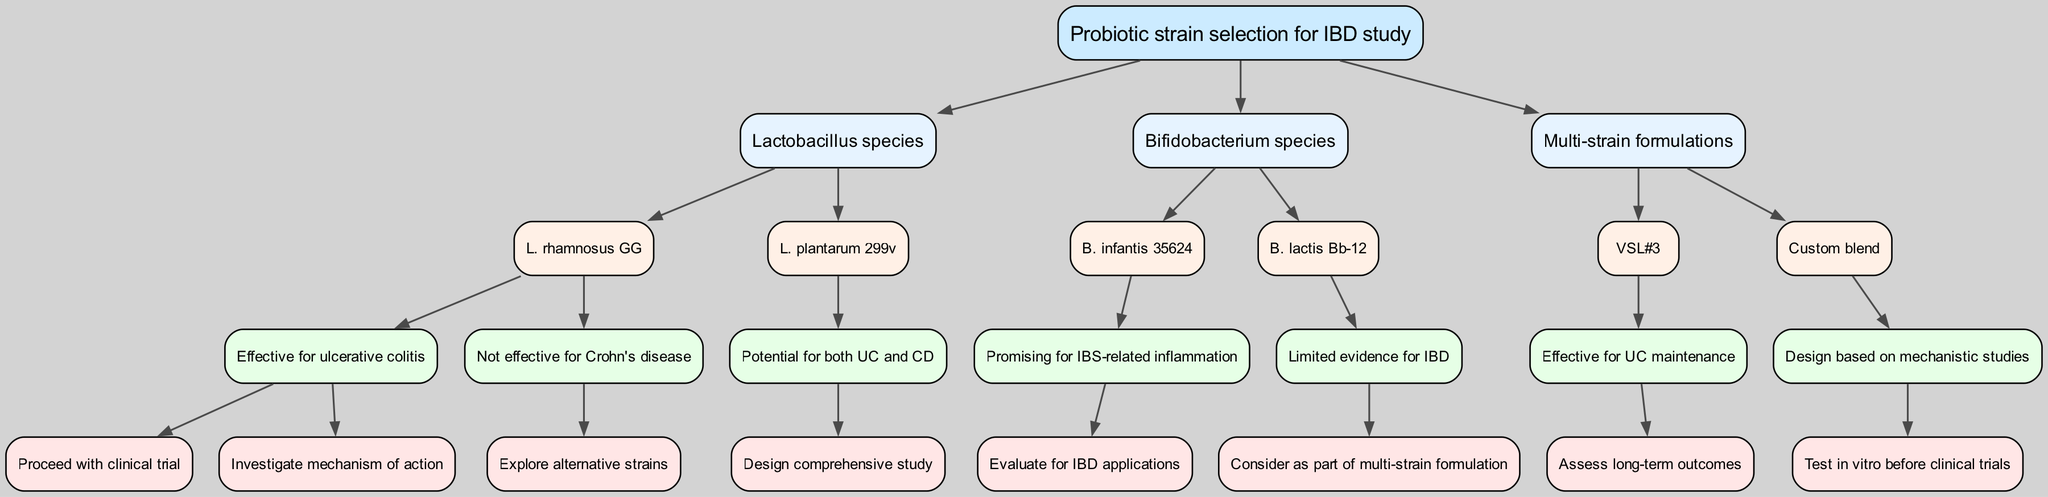What is the root node of the diagram? The root node corresponds to the main topic of the diagram, which is explicitly stated at the top. In this case, it is "Probiotic strain selection for IBD study."
Answer: Probiotic strain selection for IBD study How many main probiotic categories are there? The diagram has three primary categories branching out from the root: "Lactobacillus species," "Bifidobacterium species," and "Multi-strain formulations." Thus, the total count is three.
Answer: Three Which probiotic strain is effective for ulcerative colitis? The node states that "L. rhamnosus GG" is effective for ulcerative colitis, leading to further actions in the decision tree.
Answer: L. rhamnosus GG What should be done for L. plantarum 299v? According to the decision tree, the action advised for "L. plantarum 299v," which shows potential for both ulcerative colitis and Crohn's disease, is to "Design comprehensive study."
Answer: Design comprehensive study Which strain is promising for IBS-related inflammation? The diagram indicates that "B. infantis 35624" is recognized as promising for IBS-related inflammation, suggesting its potential relevance to IBD.
Answer: B. infantis 35624 What is the next step after assessing VSL#3 for UC maintenance? From the diagram, the next logical step after determining VSL#3's effectiveness for UC maintenance is to "Assess long-term outcomes."
Answer: Assess long-term outcomes Which action should be taken for B. lactis Bb-12? The decision tree provides that "B. lactis Bb-12" has limited evidence for IBD, recommending considering it as part of a multi-strain formulation.
Answer: Consider as part of multi-strain formulation Is L. rhamnosus GG effective for Crohn's disease? The diagram explicitly states that L. rhamnosus GG is "Not effective for Crohn's disease," thus directly answering the question.
Answer: Not effective for Crohn's disease What is the relationship between multi-strain formulations and effective treatments? The diagram suggests that multi-strain formulations are identified for specific applications. For example, "VSL#3" is effective for UC maintenance, and a custom blend should be designed based on mechanistic studies. This indicates that multi-strain formulations play a crucial role in treatment effectiveness.
Answer: Crucial role in treatment effectiveness 